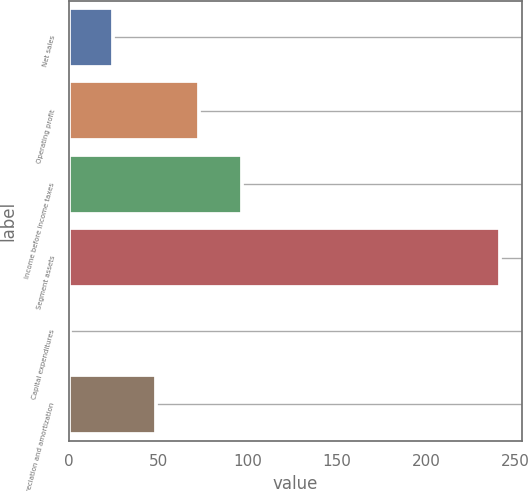Convert chart to OTSL. <chart><loc_0><loc_0><loc_500><loc_500><bar_chart><fcel>Net sales<fcel>Operating profit<fcel>Income before income taxes<fcel>Segment assets<fcel>Capital expenditures<fcel>Depreciation and amortization<nl><fcel>24.51<fcel>72.73<fcel>96.84<fcel>241.5<fcel>0.4<fcel>48.62<nl></chart> 